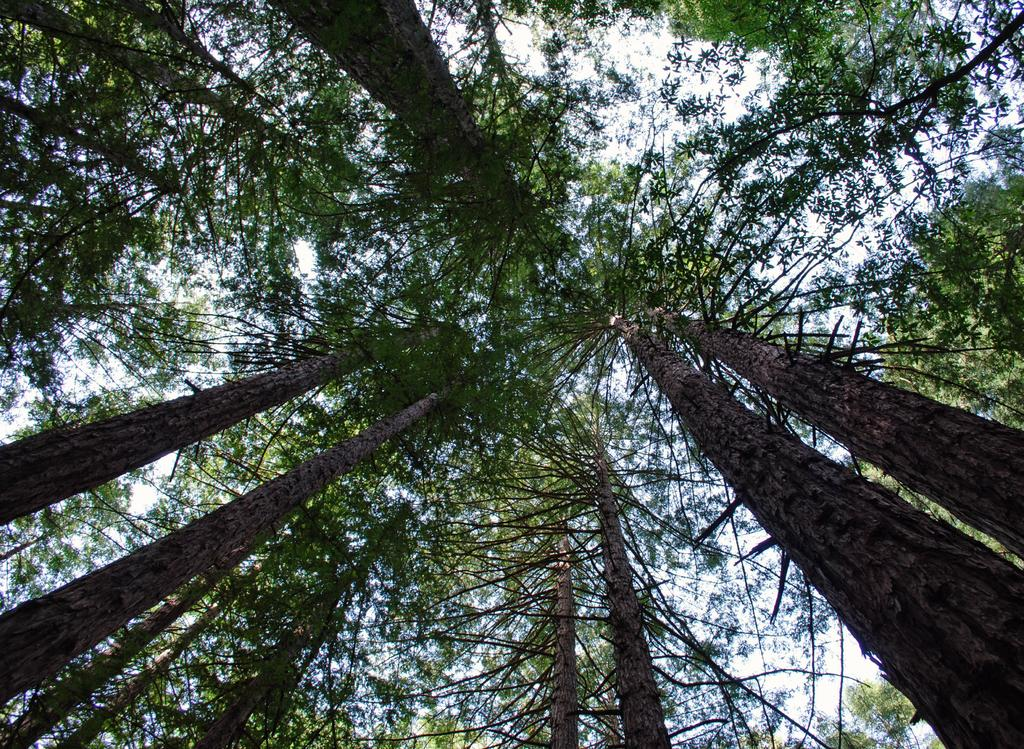What type of vegetation can be seen in the image? There are trees in the image. How tall are the trees in the image? The trees are tall in the image. What is visible behind the trees in the image? The sky is visible behind the trees in the image. What type of stage can be seen in the image? There is no stage present in the image; it features tall trees and the sky. What is the chance of rain in the image? The image does not provide any information about the weather or the chance of rain. 